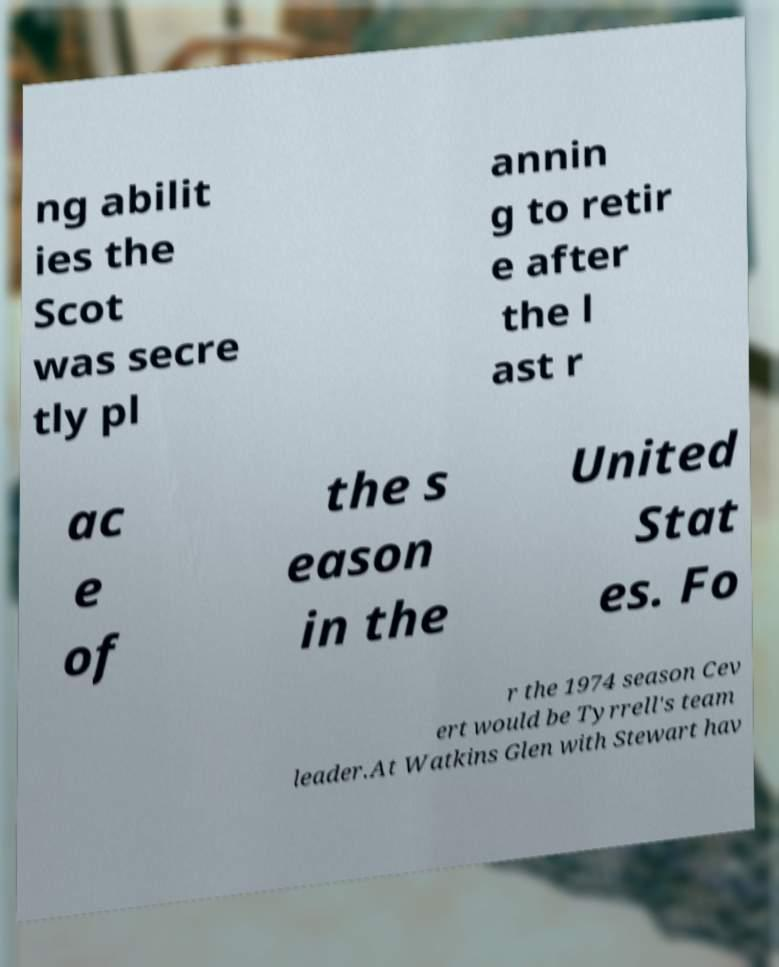Could you extract and type out the text from this image? ng abilit ies the Scot was secre tly pl annin g to retir e after the l ast r ac e of the s eason in the United Stat es. Fo r the 1974 season Cev ert would be Tyrrell's team leader.At Watkins Glen with Stewart hav 